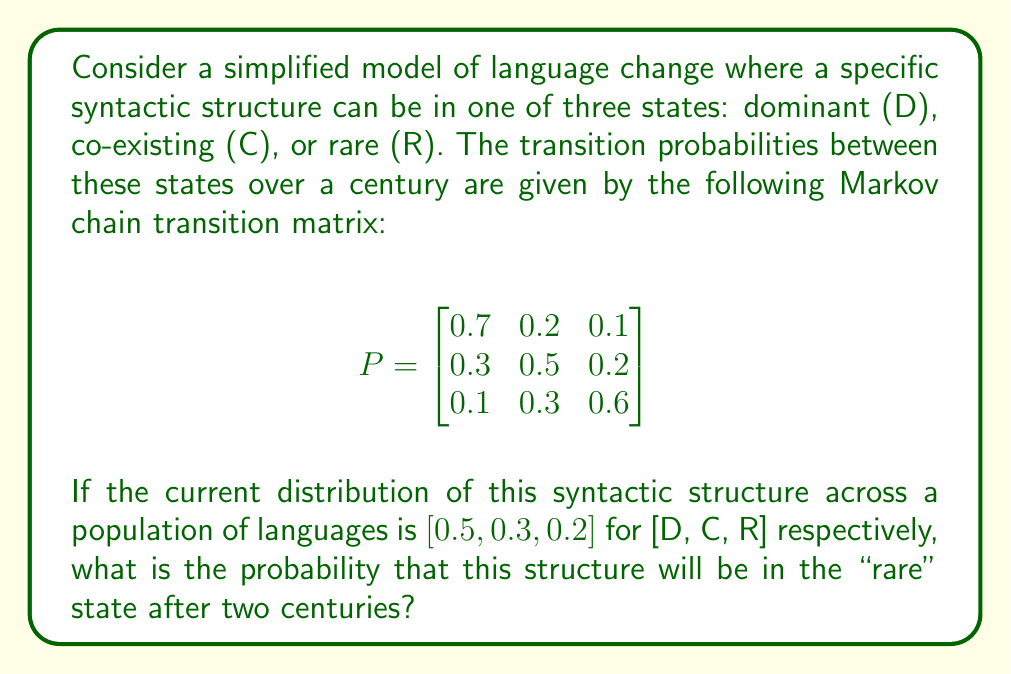Teach me how to tackle this problem. To solve this problem, we need to use the properties of Markov chains and matrix multiplication. Let's approach this step-by-step:

1) First, we need to calculate the state of the system after two centuries. This is equivalent to multiplying the initial state vector by the transition matrix twice.

2) Let's denote the initial state vector as $\pi_0 = [0.5, 0.3, 0.2]$.

3) After one century, the state will be:
   $\pi_1 = \pi_0 P$

4) After two centuries, the state will be:
   $\pi_2 = \pi_1 P = (\pi_0 P)P = \pi_0 P^2$

5) So, we need to calculate $P^2$ first:

   $$P^2 = \begin{bmatrix}
   0.7 & 0.2 & 0.1 \\
   0.3 & 0.5 & 0.2 \\
   0.1 & 0.3 & 0.6
   \end{bmatrix} \times \begin{bmatrix}
   0.7 & 0.2 & 0.1 \\
   0.3 & 0.5 & 0.2 \\
   0.1 & 0.3 & 0.6
   \end{bmatrix}$$

6) Performing this matrix multiplication:

   $$P^2 = \begin{bmatrix}
   0.56 & 0.27 & 0.17 \\
   0.37 & 0.39 & 0.24 \\
   0.22 & 0.35 & 0.43
   \end{bmatrix}$$

7) Now, we multiply $\pi_0$ by $P^2$:

   $\pi_2 = [0.5, 0.3, 0.2] \times \begin{bmatrix}
   0.56 & 0.27 & 0.17 \\
   0.37 & 0.39 & 0.24 \\
   0.22 & 0.35 & 0.43
   \end{bmatrix}$

8) Performing this multiplication:

   $\pi_2 = [0.455, 0.315, 0.23]$

9) The probability that the structure will be in the "rare" state after two centuries is the third component of $\pi_2$, which is 0.23 or 23%.
Answer: 0.23 